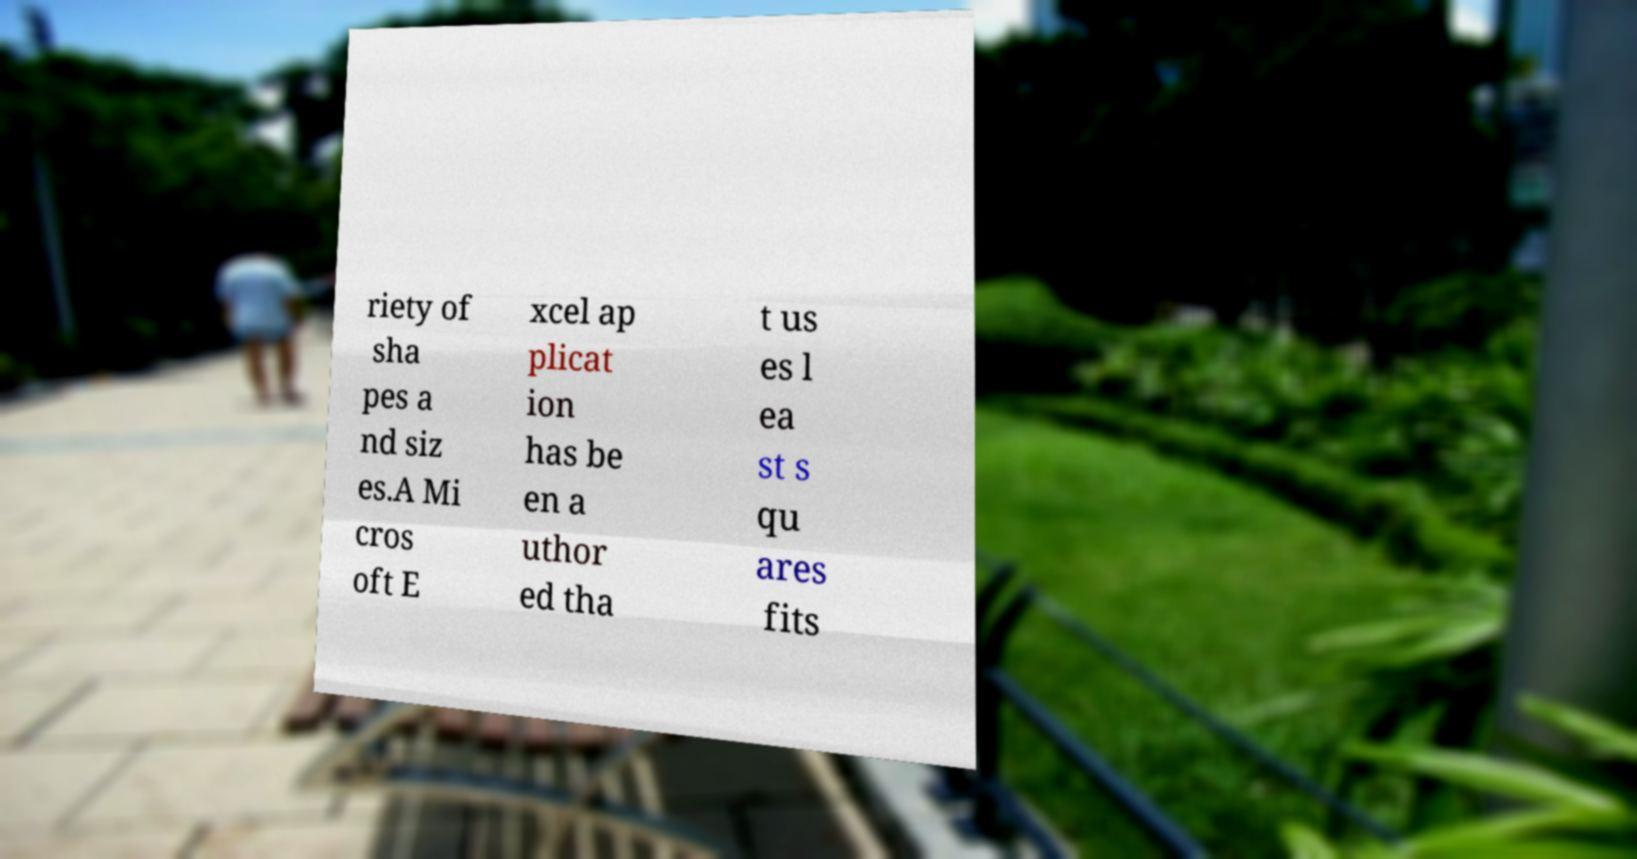Please identify and transcribe the text found in this image. riety of sha pes a nd siz es.A Mi cros oft E xcel ap plicat ion has be en a uthor ed tha t us es l ea st s qu ares fits 